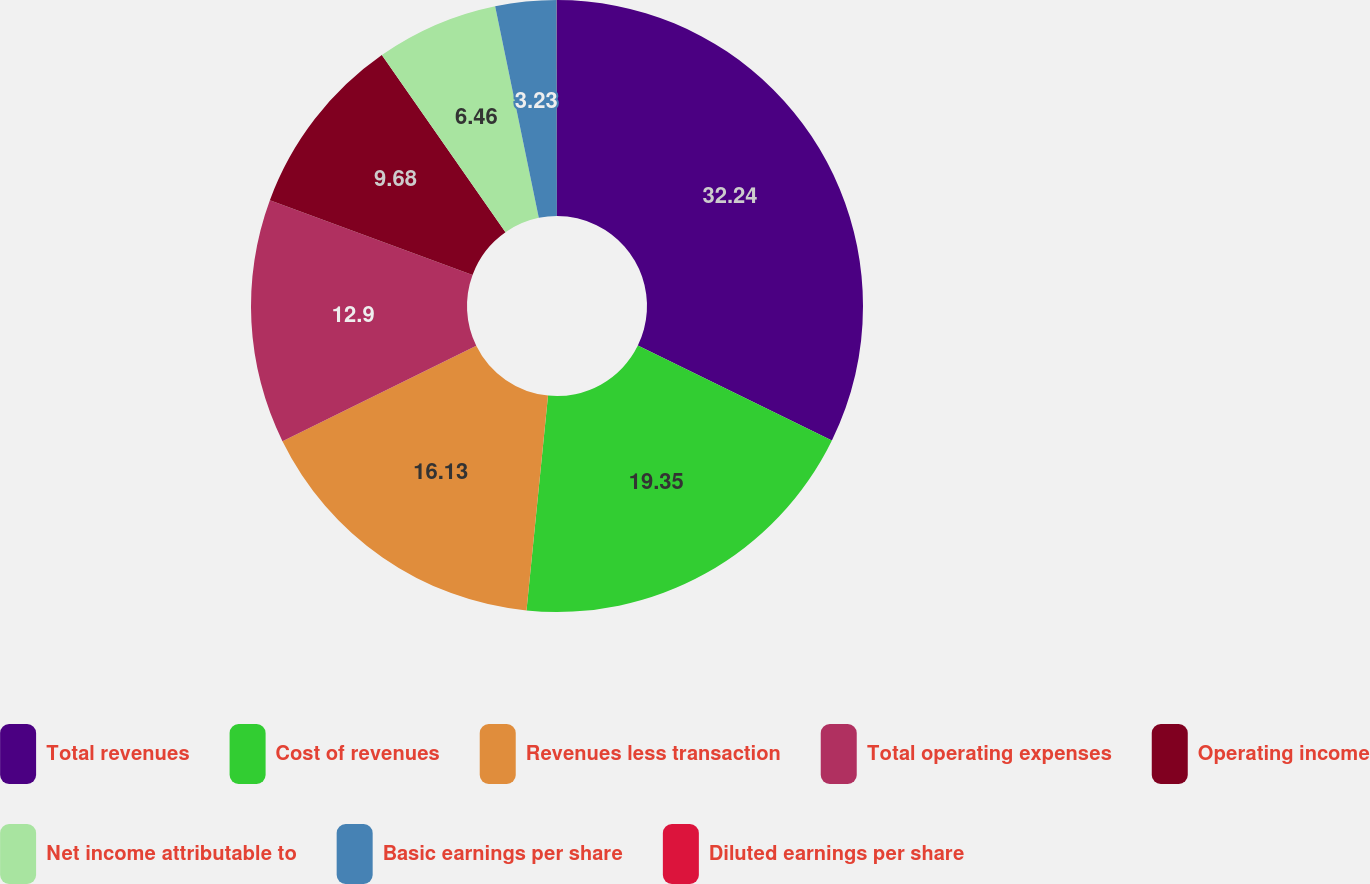<chart> <loc_0><loc_0><loc_500><loc_500><pie_chart><fcel>Total revenues<fcel>Cost of revenues<fcel>Revenues less transaction<fcel>Total operating expenses<fcel>Operating income<fcel>Net income attributable to<fcel>Basic earnings per share<fcel>Diluted earnings per share<nl><fcel>32.24%<fcel>19.35%<fcel>16.13%<fcel>12.9%<fcel>9.68%<fcel>6.46%<fcel>3.23%<fcel>0.01%<nl></chart> 